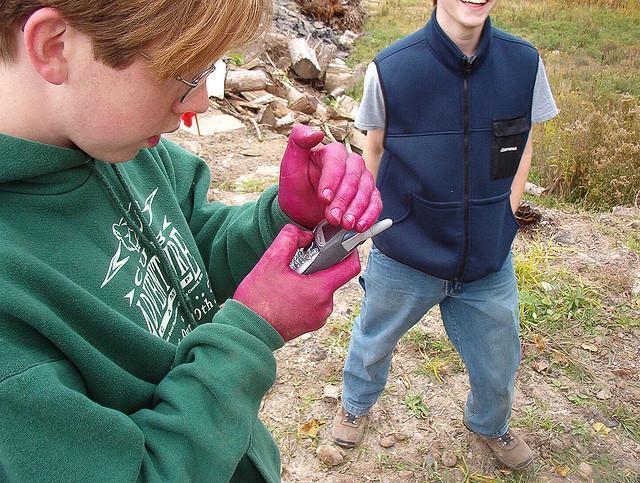Why is the boy blocking the view of his phone?
Make your selection and explain in format: 'Answer: answer
Rationale: rationale.'
Options: Visibility, safety, in anger, as joke. Answer: visibility.
Rationale: Another person is nearby.  the hand is providing privacy. 